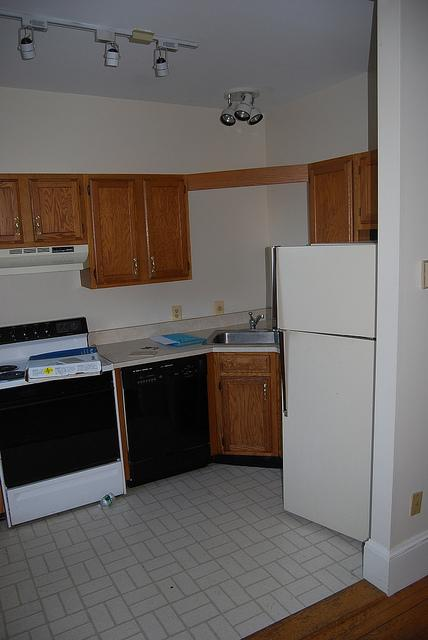What kind of cable is used in the lower right socket? Please explain your reasoning. coax. A coax cable is seen. 